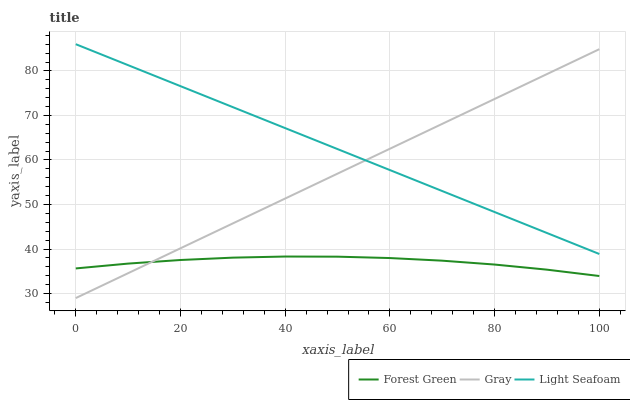Does Forest Green have the minimum area under the curve?
Answer yes or no. Yes. Does Light Seafoam have the maximum area under the curve?
Answer yes or no. Yes. Does Light Seafoam have the minimum area under the curve?
Answer yes or no. No. Does Forest Green have the maximum area under the curve?
Answer yes or no. No. Is Gray the smoothest?
Answer yes or no. Yes. Is Forest Green the roughest?
Answer yes or no. Yes. Is Light Seafoam the smoothest?
Answer yes or no. No. Is Light Seafoam the roughest?
Answer yes or no. No. Does Gray have the lowest value?
Answer yes or no. Yes. Does Forest Green have the lowest value?
Answer yes or no. No. Does Light Seafoam have the highest value?
Answer yes or no. Yes. Does Forest Green have the highest value?
Answer yes or no. No. Is Forest Green less than Light Seafoam?
Answer yes or no. Yes. Is Light Seafoam greater than Forest Green?
Answer yes or no. Yes. Does Forest Green intersect Gray?
Answer yes or no. Yes. Is Forest Green less than Gray?
Answer yes or no. No. Is Forest Green greater than Gray?
Answer yes or no. No. Does Forest Green intersect Light Seafoam?
Answer yes or no. No. 